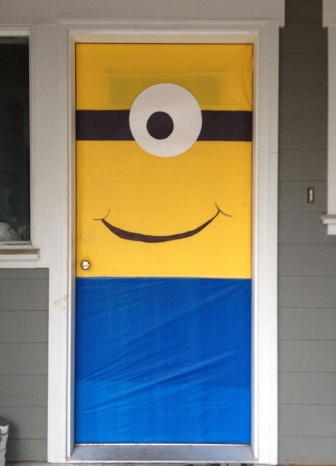Can you tell me more about the design elements visible in the image? Certainly! The image features a door prominently adorned with a minion poster divided into three horizontal sections, each contributing to the representation of a minion from 'Despicable Me'. The top section is bright yellow with a simplistic depiction of a minion's eye. The middle black band represents the goggles' strap, creating a clear divide between the yellow and blue sections, with the latter mimicking the minion's overalls. This poster brings vibrant colors to the door, contrasting starkly with the house's gray facade. Additionally, there's a window on the left of the door that adds a design balance, making the overall composition visually interesting and playful. 